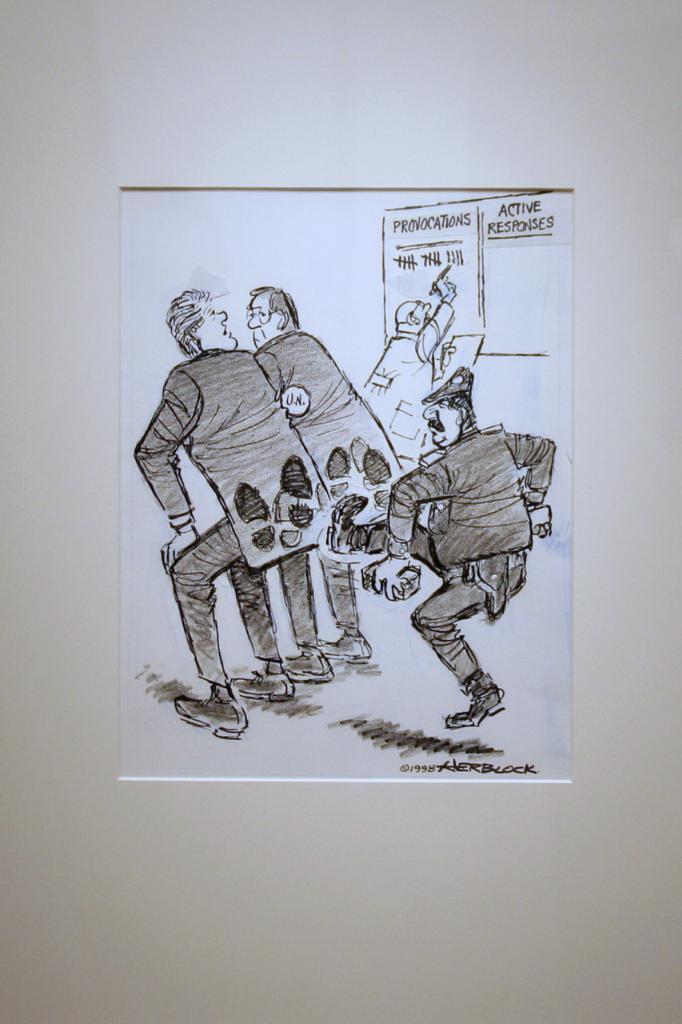Could you give a brief overview of what you see in this image? In this image there is a paper on the wall on which we can see there is a person kicking other two people beside that there is some text. 